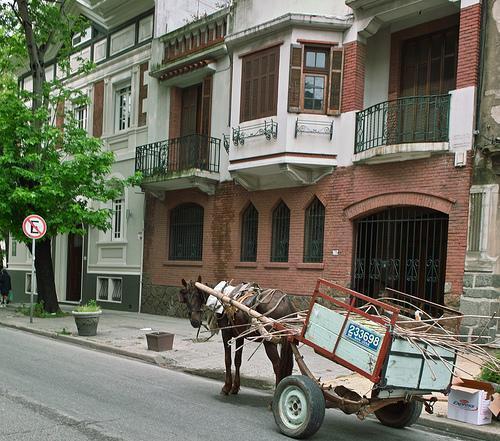Why is the horse attached to the cart with wheels?
Answer the question by selecting the correct answer among the 4 following choices and explain your choice with a short sentence. The answer should be formatted with the following format: `Answer: choice
Rationale: rationale.`
Options: To punish, to pull, to eat, to heal. Answer: to pull.
Rationale: He is being used to pull stuff in the cart. 